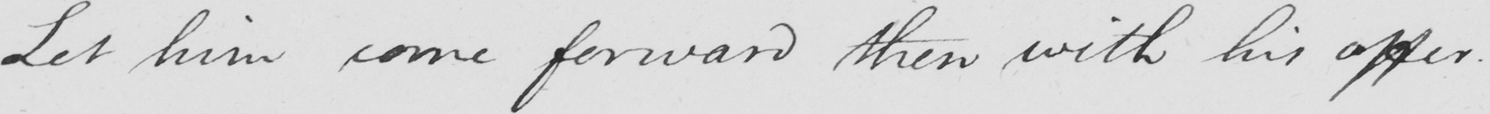What does this handwritten line say? Let him come forward then with his offer . 